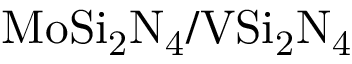Convert formula to latex. <formula><loc_0><loc_0><loc_500><loc_500>M o S i _ { 2 } N _ { 4 } / V S i _ { 2 } N _ { 4 }</formula> 